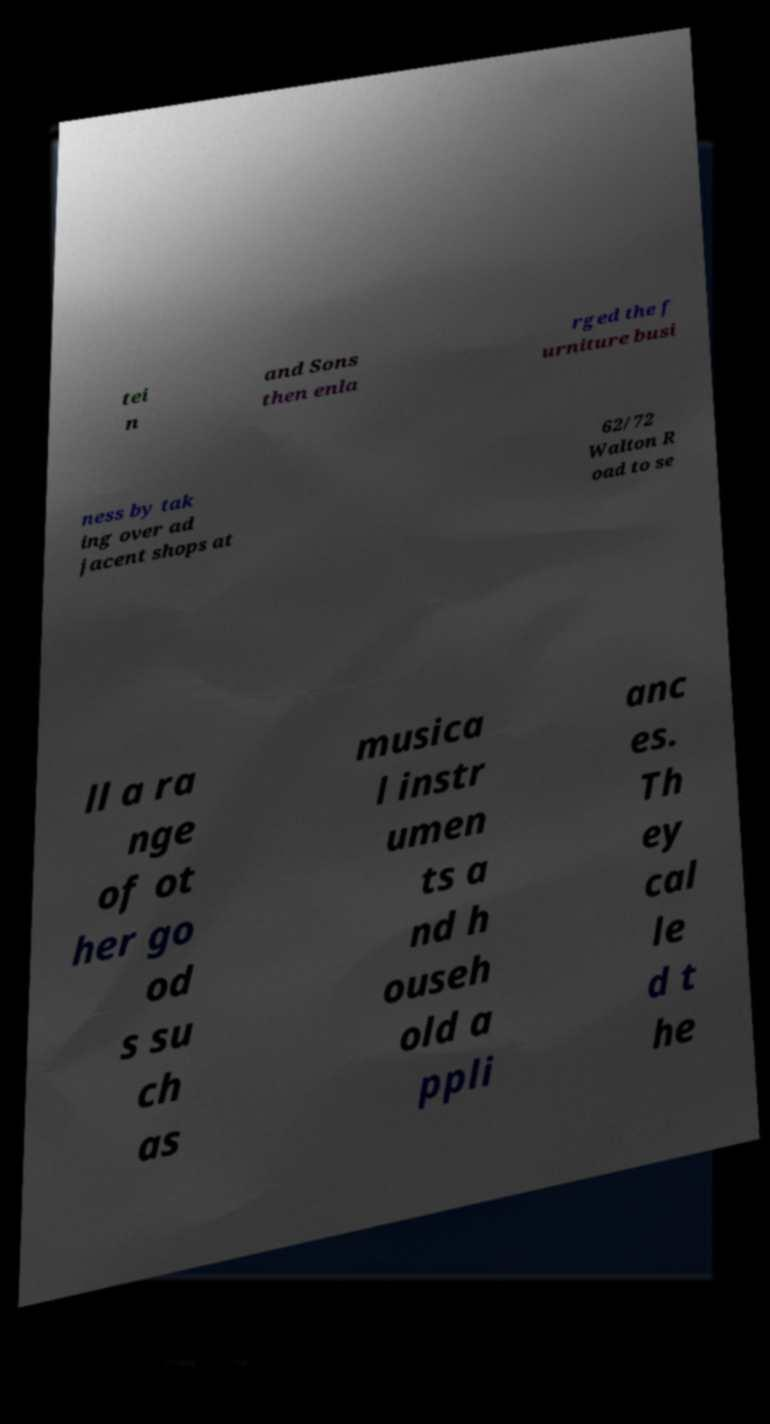I need the written content from this picture converted into text. Can you do that? tei n and Sons then enla rged the f urniture busi ness by tak ing over ad jacent shops at 62/72 Walton R oad to se ll a ra nge of ot her go od s su ch as musica l instr umen ts a nd h ouseh old a ppli anc es. Th ey cal le d t he 